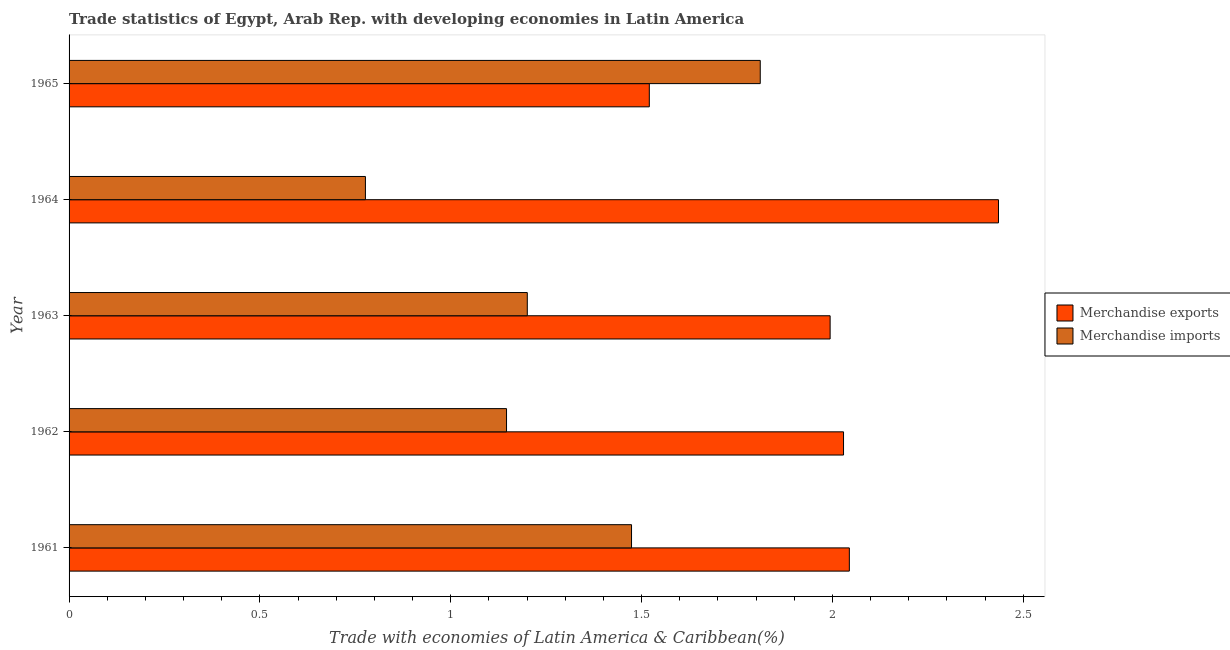How many different coloured bars are there?
Give a very brief answer. 2. How many groups of bars are there?
Keep it short and to the point. 5. Are the number of bars on each tick of the Y-axis equal?
Offer a very short reply. Yes. How many bars are there on the 3rd tick from the top?
Ensure brevity in your answer.  2. What is the label of the 3rd group of bars from the top?
Make the answer very short. 1963. In how many cases, is the number of bars for a given year not equal to the number of legend labels?
Keep it short and to the point. 0. What is the merchandise exports in 1965?
Keep it short and to the point. 1.52. Across all years, what is the maximum merchandise exports?
Ensure brevity in your answer.  2.43. Across all years, what is the minimum merchandise imports?
Keep it short and to the point. 0.78. In which year was the merchandise imports maximum?
Provide a succinct answer. 1965. In which year was the merchandise exports minimum?
Offer a terse response. 1965. What is the total merchandise imports in the graph?
Keep it short and to the point. 6.41. What is the difference between the merchandise exports in 1962 and that in 1964?
Provide a short and direct response. -0.41. What is the difference between the merchandise imports in 1963 and the merchandise exports in 1965?
Provide a short and direct response. -0.32. What is the average merchandise exports per year?
Make the answer very short. 2. In the year 1965, what is the difference between the merchandise exports and merchandise imports?
Give a very brief answer. -0.29. What is the ratio of the merchandise imports in 1963 to that in 1964?
Your answer should be compact. 1.55. Is the merchandise imports in 1962 less than that in 1965?
Make the answer very short. Yes. What is the difference between the highest and the second highest merchandise exports?
Offer a terse response. 0.39. What is the difference between the highest and the lowest merchandise imports?
Offer a terse response. 1.03. In how many years, is the merchandise exports greater than the average merchandise exports taken over all years?
Make the answer very short. 3. What does the 2nd bar from the top in 1964 represents?
Give a very brief answer. Merchandise exports. How many years are there in the graph?
Make the answer very short. 5. What is the difference between two consecutive major ticks on the X-axis?
Make the answer very short. 0.5. Does the graph contain any zero values?
Your answer should be compact. No. Does the graph contain grids?
Your answer should be compact. No. Where does the legend appear in the graph?
Offer a very short reply. Center right. What is the title of the graph?
Make the answer very short. Trade statistics of Egypt, Arab Rep. with developing economies in Latin America. What is the label or title of the X-axis?
Your response must be concise. Trade with economies of Latin America & Caribbean(%). What is the label or title of the Y-axis?
Ensure brevity in your answer.  Year. What is the Trade with economies of Latin America & Caribbean(%) of Merchandise exports in 1961?
Offer a very short reply. 2.04. What is the Trade with economies of Latin America & Caribbean(%) in Merchandise imports in 1961?
Your answer should be very brief. 1.47. What is the Trade with economies of Latin America & Caribbean(%) of Merchandise exports in 1962?
Give a very brief answer. 2.03. What is the Trade with economies of Latin America & Caribbean(%) of Merchandise imports in 1962?
Keep it short and to the point. 1.15. What is the Trade with economies of Latin America & Caribbean(%) of Merchandise exports in 1963?
Ensure brevity in your answer.  1.99. What is the Trade with economies of Latin America & Caribbean(%) in Merchandise imports in 1963?
Offer a terse response. 1.2. What is the Trade with economies of Latin America & Caribbean(%) in Merchandise exports in 1964?
Keep it short and to the point. 2.43. What is the Trade with economies of Latin America & Caribbean(%) of Merchandise imports in 1964?
Make the answer very short. 0.78. What is the Trade with economies of Latin America & Caribbean(%) in Merchandise exports in 1965?
Your response must be concise. 1.52. What is the Trade with economies of Latin America & Caribbean(%) of Merchandise imports in 1965?
Your response must be concise. 1.81. Across all years, what is the maximum Trade with economies of Latin America & Caribbean(%) of Merchandise exports?
Offer a terse response. 2.43. Across all years, what is the maximum Trade with economies of Latin America & Caribbean(%) of Merchandise imports?
Your response must be concise. 1.81. Across all years, what is the minimum Trade with economies of Latin America & Caribbean(%) of Merchandise exports?
Offer a terse response. 1.52. Across all years, what is the minimum Trade with economies of Latin America & Caribbean(%) of Merchandise imports?
Make the answer very short. 0.78. What is the total Trade with economies of Latin America & Caribbean(%) in Merchandise exports in the graph?
Your answer should be very brief. 10.02. What is the total Trade with economies of Latin America & Caribbean(%) in Merchandise imports in the graph?
Keep it short and to the point. 6.41. What is the difference between the Trade with economies of Latin America & Caribbean(%) of Merchandise exports in 1961 and that in 1962?
Give a very brief answer. 0.02. What is the difference between the Trade with economies of Latin America & Caribbean(%) in Merchandise imports in 1961 and that in 1962?
Your response must be concise. 0.33. What is the difference between the Trade with economies of Latin America & Caribbean(%) in Merchandise exports in 1961 and that in 1963?
Your answer should be very brief. 0.05. What is the difference between the Trade with economies of Latin America & Caribbean(%) of Merchandise imports in 1961 and that in 1963?
Ensure brevity in your answer.  0.27. What is the difference between the Trade with economies of Latin America & Caribbean(%) in Merchandise exports in 1961 and that in 1964?
Make the answer very short. -0.39. What is the difference between the Trade with economies of Latin America & Caribbean(%) of Merchandise imports in 1961 and that in 1964?
Your answer should be very brief. 0.7. What is the difference between the Trade with economies of Latin America & Caribbean(%) of Merchandise exports in 1961 and that in 1965?
Your answer should be very brief. 0.52. What is the difference between the Trade with economies of Latin America & Caribbean(%) of Merchandise imports in 1961 and that in 1965?
Your answer should be compact. -0.34. What is the difference between the Trade with economies of Latin America & Caribbean(%) in Merchandise exports in 1962 and that in 1963?
Keep it short and to the point. 0.04. What is the difference between the Trade with economies of Latin America & Caribbean(%) in Merchandise imports in 1962 and that in 1963?
Keep it short and to the point. -0.05. What is the difference between the Trade with economies of Latin America & Caribbean(%) in Merchandise exports in 1962 and that in 1964?
Offer a terse response. -0.41. What is the difference between the Trade with economies of Latin America & Caribbean(%) of Merchandise imports in 1962 and that in 1964?
Make the answer very short. 0.37. What is the difference between the Trade with economies of Latin America & Caribbean(%) in Merchandise exports in 1962 and that in 1965?
Offer a terse response. 0.51. What is the difference between the Trade with economies of Latin America & Caribbean(%) of Merchandise imports in 1962 and that in 1965?
Offer a very short reply. -0.66. What is the difference between the Trade with economies of Latin America & Caribbean(%) of Merchandise exports in 1963 and that in 1964?
Your answer should be very brief. -0.44. What is the difference between the Trade with economies of Latin America & Caribbean(%) of Merchandise imports in 1963 and that in 1964?
Your response must be concise. 0.42. What is the difference between the Trade with economies of Latin America & Caribbean(%) of Merchandise exports in 1963 and that in 1965?
Provide a succinct answer. 0.47. What is the difference between the Trade with economies of Latin America & Caribbean(%) of Merchandise imports in 1963 and that in 1965?
Offer a very short reply. -0.61. What is the difference between the Trade with economies of Latin America & Caribbean(%) in Merchandise exports in 1964 and that in 1965?
Give a very brief answer. 0.91. What is the difference between the Trade with economies of Latin America & Caribbean(%) in Merchandise imports in 1964 and that in 1965?
Provide a short and direct response. -1.03. What is the difference between the Trade with economies of Latin America & Caribbean(%) of Merchandise exports in 1961 and the Trade with economies of Latin America & Caribbean(%) of Merchandise imports in 1962?
Offer a very short reply. 0.9. What is the difference between the Trade with economies of Latin America & Caribbean(%) in Merchandise exports in 1961 and the Trade with economies of Latin America & Caribbean(%) in Merchandise imports in 1963?
Offer a terse response. 0.84. What is the difference between the Trade with economies of Latin America & Caribbean(%) of Merchandise exports in 1961 and the Trade with economies of Latin America & Caribbean(%) of Merchandise imports in 1964?
Ensure brevity in your answer.  1.27. What is the difference between the Trade with economies of Latin America & Caribbean(%) of Merchandise exports in 1961 and the Trade with economies of Latin America & Caribbean(%) of Merchandise imports in 1965?
Offer a terse response. 0.23. What is the difference between the Trade with economies of Latin America & Caribbean(%) in Merchandise exports in 1962 and the Trade with economies of Latin America & Caribbean(%) in Merchandise imports in 1963?
Offer a very short reply. 0.83. What is the difference between the Trade with economies of Latin America & Caribbean(%) of Merchandise exports in 1962 and the Trade with economies of Latin America & Caribbean(%) of Merchandise imports in 1964?
Give a very brief answer. 1.25. What is the difference between the Trade with economies of Latin America & Caribbean(%) of Merchandise exports in 1962 and the Trade with economies of Latin America & Caribbean(%) of Merchandise imports in 1965?
Your response must be concise. 0.22. What is the difference between the Trade with economies of Latin America & Caribbean(%) in Merchandise exports in 1963 and the Trade with economies of Latin America & Caribbean(%) in Merchandise imports in 1964?
Keep it short and to the point. 1.22. What is the difference between the Trade with economies of Latin America & Caribbean(%) in Merchandise exports in 1963 and the Trade with economies of Latin America & Caribbean(%) in Merchandise imports in 1965?
Provide a short and direct response. 0.18. What is the difference between the Trade with economies of Latin America & Caribbean(%) in Merchandise exports in 1964 and the Trade with economies of Latin America & Caribbean(%) in Merchandise imports in 1965?
Ensure brevity in your answer.  0.62. What is the average Trade with economies of Latin America & Caribbean(%) of Merchandise exports per year?
Your answer should be compact. 2. What is the average Trade with economies of Latin America & Caribbean(%) in Merchandise imports per year?
Your response must be concise. 1.28. In the year 1961, what is the difference between the Trade with economies of Latin America & Caribbean(%) in Merchandise exports and Trade with economies of Latin America & Caribbean(%) in Merchandise imports?
Offer a very short reply. 0.57. In the year 1962, what is the difference between the Trade with economies of Latin America & Caribbean(%) in Merchandise exports and Trade with economies of Latin America & Caribbean(%) in Merchandise imports?
Your response must be concise. 0.88. In the year 1963, what is the difference between the Trade with economies of Latin America & Caribbean(%) of Merchandise exports and Trade with economies of Latin America & Caribbean(%) of Merchandise imports?
Offer a very short reply. 0.79. In the year 1964, what is the difference between the Trade with economies of Latin America & Caribbean(%) in Merchandise exports and Trade with economies of Latin America & Caribbean(%) in Merchandise imports?
Give a very brief answer. 1.66. In the year 1965, what is the difference between the Trade with economies of Latin America & Caribbean(%) of Merchandise exports and Trade with economies of Latin America & Caribbean(%) of Merchandise imports?
Make the answer very short. -0.29. What is the ratio of the Trade with economies of Latin America & Caribbean(%) of Merchandise exports in 1961 to that in 1962?
Provide a short and direct response. 1.01. What is the ratio of the Trade with economies of Latin America & Caribbean(%) in Merchandise exports in 1961 to that in 1963?
Your answer should be very brief. 1.03. What is the ratio of the Trade with economies of Latin America & Caribbean(%) of Merchandise imports in 1961 to that in 1963?
Provide a succinct answer. 1.23. What is the ratio of the Trade with economies of Latin America & Caribbean(%) in Merchandise exports in 1961 to that in 1964?
Your answer should be very brief. 0.84. What is the ratio of the Trade with economies of Latin America & Caribbean(%) in Merchandise imports in 1961 to that in 1964?
Provide a succinct answer. 1.9. What is the ratio of the Trade with economies of Latin America & Caribbean(%) of Merchandise exports in 1961 to that in 1965?
Provide a succinct answer. 1.34. What is the ratio of the Trade with economies of Latin America & Caribbean(%) of Merchandise imports in 1961 to that in 1965?
Offer a very short reply. 0.81. What is the ratio of the Trade with economies of Latin America & Caribbean(%) in Merchandise exports in 1962 to that in 1963?
Your answer should be compact. 1.02. What is the ratio of the Trade with economies of Latin America & Caribbean(%) of Merchandise imports in 1962 to that in 1963?
Your answer should be compact. 0.95. What is the ratio of the Trade with economies of Latin America & Caribbean(%) of Merchandise exports in 1962 to that in 1964?
Offer a terse response. 0.83. What is the ratio of the Trade with economies of Latin America & Caribbean(%) of Merchandise imports in 1962 to that in 1964?
Make the answer very short. 1.48. What is the ratio of the Trade with economies of Latin America & Caribbean(%) in Merchandise exports in 1962 to that in 1965?
Ensure brevity in your answer.  1.33. What is the ratio of the Trade with economies of Latin America & Caribbean(%) in Merchandise imports in 1962 to that in 1965?
Provide a succinct answer. 0.63. What is the ratio of the Trade with economies of Latin America & Caribbean(%) of Merchandise exports in 1963 to that in 1964?
Your response must be concise. 0.82. What is the ratio of the Trade with economies of Latin America & Caribbean(%) of Merchandise imports in 1963 to that in 1964?
Offer a terse response. 1.55. What is the ratio of the Trade with economies of Latin America & Caribbean(%) of Merchandise exports in 1963 to that in 1965?
Offer a very short reply. 1.31. What is the ratio of the Trade with economies of Latin America & Caribbean(%) of Merchandise imports in 1963 to that in 1965?
Provide a succinct answer. 0.66. What is the ratio of the Trade with economies of Latin America & Caribbean(%) of Merchandise exports in 1964 to that in 1965?
Ensure brevity in your answer.  1.6. What is the ratio of the Trade with economies of Latin America & Caribbean(%) of Merchandise imports in 1964 to that in 1965?
Provide a short and direct response. 0.43. What is the difference between the highest and the second highest Trade with economies of Latin America & Caribbean(%) in Merchandise exports?
Offer a very short reply. 0.39. What is the difference between the highest and the second highest Trade with economies of Latin America & Caribbean(%) of Merchandise imports?
Make the answer very short. 0.34. What is the difference between the highest and the lowest Trade with economies of Latin America & Caribbean(%) of Merchandise exports?
Give a very brief answer. 0.91. What is the difference between the highest and the lowest Trade with economies of Latin America & Caribbean(%) in Merchandise imports?
Ensure brevity in your answer.  1.03. 